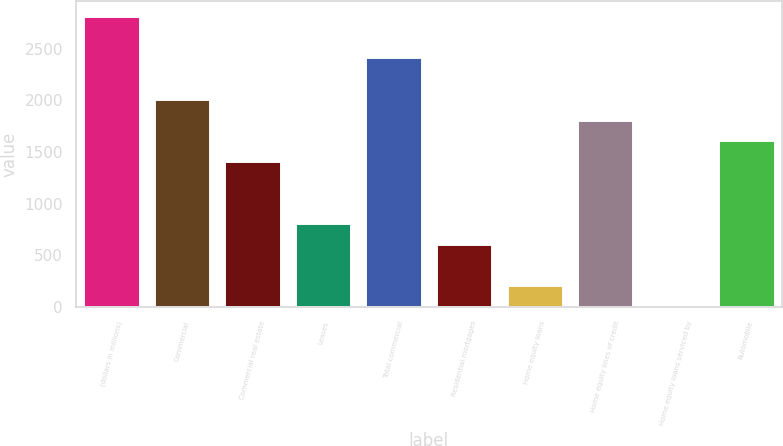Convert chart to OTSL. <chart><loc_0><loc_0><loc_500><loc_500><bar_chart><fcel>(dollars in millions)<fcel>Commercial<fcel>Commercial real estate<fcel>Leases<fcel>Total commercial<fcel>Residential mortgages<fcel>Home equity loans<fcel>Home equity lines of credit<fcel>Home equity loans serviced by<fcel>Automobile<nl><fcel>2818.8<fcel>2016<fcel>1413.9<fcel>811.8<fcel>2417.4<fcel>611.1<fcel>209.7<fcel>1815.3<fcel>9<fcel>1614.6<nl></chart> 